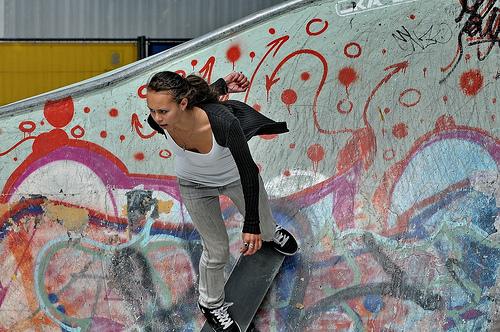Is she a police officer?
Answer briefly. No. Should she be wearing headgear?
Short answer required. Yes. Where is this activity taking place?
Keep it brief. Skate park. 